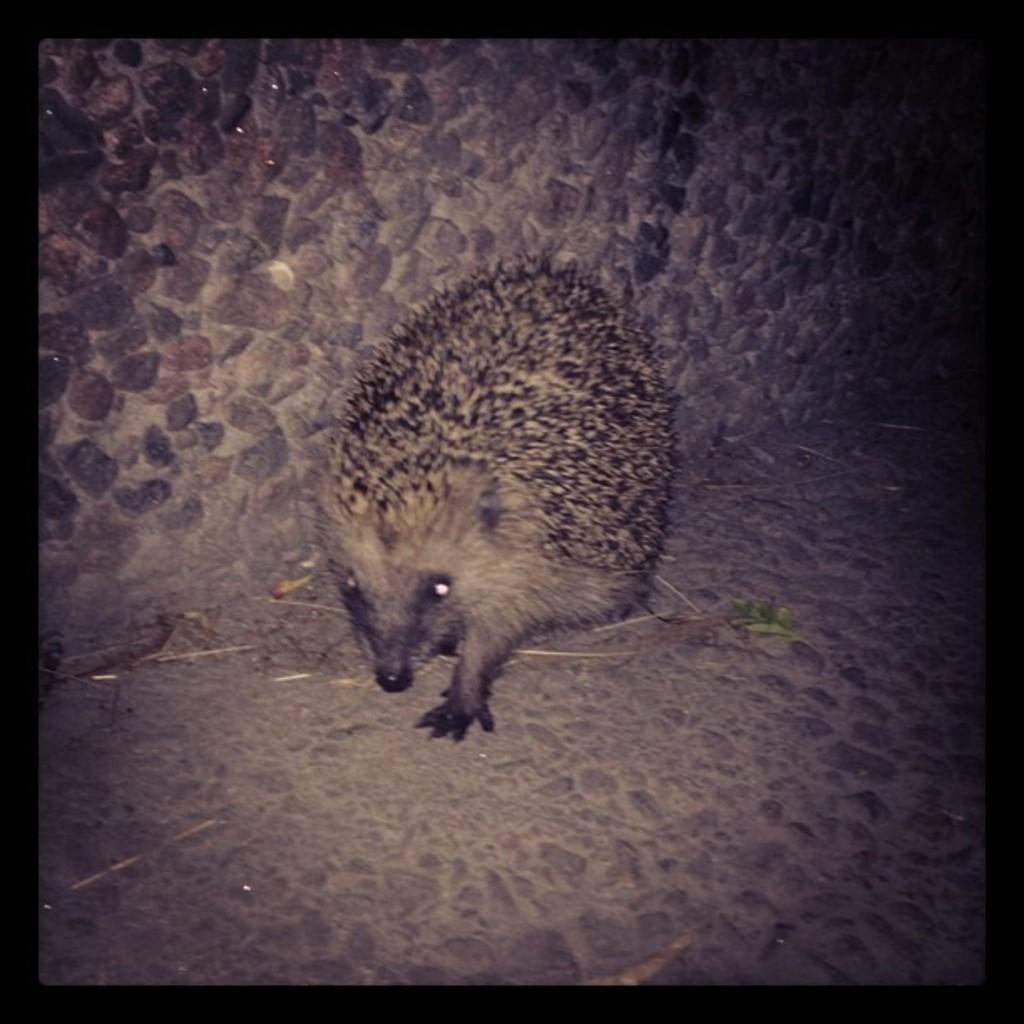What type of image is being described? The image is an edited picture. What can be seen in the image besides the edited elements? There is an animal in the image. What is visible in the background of the image? There is a wall in the background of the image. What type of beef is being served on the plate in the image? There is no plate or beef present in the image; it features an animal and a wall in the background. What type of game is being played in the image? There is no game being played in the image; it features an animal and a wall in the background. 